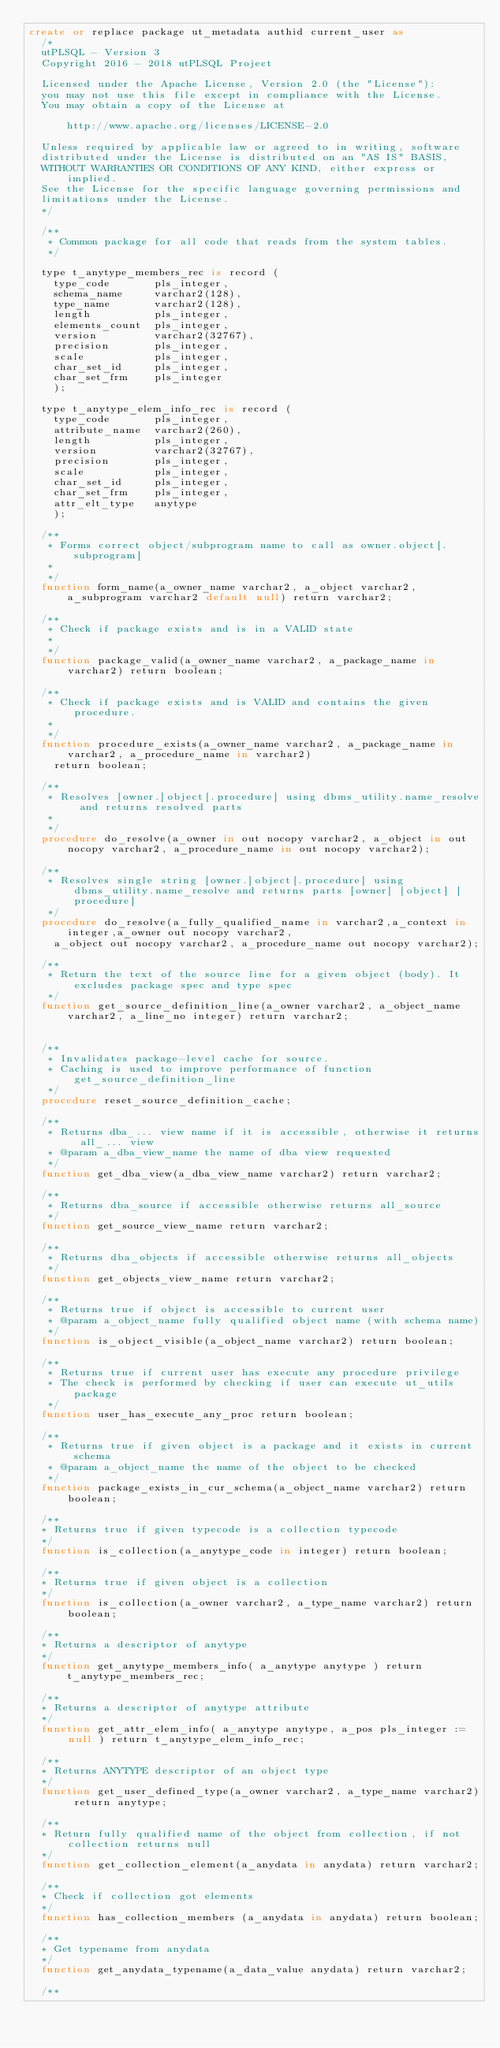Convert code to text. <code><loc_0><loc_0><loc_500><loc_500><_SQL_>create or replace package ut_metadata authid current_user as
  /*
  utPLSQL - Version 3
  Copyright 2016 - 2018 utPLSQL Project

  Licensed under the Apache License, Version 2.0 (the "License"):
  you may not use this file except in compliance with the License.
  You may obtain a copy of the License at

      http://www.apache.org/licenses/LICENSE-2.0

  Unless required by applicable law or agreed to in writing, software
  distributed under the License is distributed on an "AS IS" BASIS,
  WITHOUT WARRANTIES OR CONDITIONS OF ANY KIND, either express or implied.
  See the License for the specific language governing permissions and
  limitations under the License.
  */

  /**
   * Common package for all code that reads from the system tables.
   */

  type t_anytype_members_rec is record (
    type_code       pls_integer,
    schema_name     varchar2(128),
    type_name       varchar2(128),
    length          pls_integer,
    elements_count  pls_integer,
    version         varchar2(32767),
    precision       pls_integer,
    scale           pls_integer,
    char_set_id     pls_integer,
    char_set_frm    pls_integer
    );

  type t_anytype_elem_info_rec is record (
    type_code       pls_integer,
    attribute_name  varchar2(260),
    length          pls_integer,
    version         varchar2(32767),
    precision       pls_integer,
    scale           pls_integer,
    char_set_id     pls_integer,
    char_set_frm    pls_integer,
    attr_elt_type   anytype
    );

  /**
   * Forms correct object/subprogram name to call as owner.object[.subprogram]
   *
   */
  function form_name(a_owner_name varchar2, a_object varchar2, a_subprogram varchar2 default null) return varchar2;

  /**
   * Check if package exists and is in a VALID state
   *
   */
  function package_valid(a_owner_name varchar2, a_package_name in varchar2) return boolean;

  /**
   * Check if package exists and is VALID and contains the given procedure.
   *
   */
  function procedure_exists(a_owner_name varchar2, a_package_name in varchar2, a_procedure_name in varchar2)
    return boolean;

  /**
   * Resolves [owner.]object[.procedure] using dbms_utility.name_resolve and returns resolved parts
   *
   */
  procedure do_resolve(a_owner in out nocopy varchar2, a_object in out nocopy varchar2, a_procedure_name in out nocopy varchar2);

  /**
   * Resolves single string [owner.]object[.procedure] using dbms_utility.name_resolve and returns parts [owner] [object] [procedure]
   */
  procedure do_resolve(a_fully_qualified_name in varchar2,a_context in integer,a_owner out nocopy varchar2, 
    a_object out nocopy varchar2, a_procedure_name out nocopy varchar2);

  /**
   * Return the text of the source line for a given object (body). It excludes package spec and type spec
   */
  function get_source_definition_line(a_owner varchar2, a_object_name varchar2, a_line_no integer) return varchar2;


  /**
   * Invalidates package-level cache for source.
   * Caching is used to improve performance of function get_source_definition_line
   */
  procedure reset_source_definition_cache;

  /**
   * Returns dba_... view name if it is accessible, otherwise it returns all_... view
   * @param a_dba_view_name the name of dba view requested
   */
  function get_dba_view(a_dba_view_name varchar2) return varchar2;

  /**
   * Returns dba_source if accessible otherwise returns all_source
   */
  function get_source_view_name return varchar2;

  /**
   * Returns dba_objects if accessible otherwise returns all_objects
   */
  function get_objects_view_name return varchar2;

  /**
   * Returns true if object is accessible to current user
   * @param a_object_name fully qualified object name (with schema name)
   */
  function is_object_visible(a_object_name varchar2) return boolean;

  /**
   * Returns true if current user has execute any procedure privilege
   * The check is performed by checking if user can execute ut_utils package
   */
  function user_has_execute_any_proc return boolean;

  /**
   * Returns true if given object is a package and it exists in current schema
   * @param a_object_name the name of the object to be checked
   */
  function package_exists_in_cur_schema(a_object_name varchar2) return boolean;

  /**
  * Returns true if given typecode is a collection typecode
  */
  function is_collection(a_anytype_code in integer) return boolean;

  /**
  * Returns true if given object is a collection
  */
  function is_collection(a_owner varchar2, a_type_name varchar2) return boolean;

  /**
  * Returns a descriptor of anytype
  */
  function get_anytype_members_info( a_anytype anytype ) return t_anytype_members_rec;

  /**
  * Returns a descriptor of anytype attribute
  */
  function get_attr_elem_info( a_anytype anytype, a_pos pls_integer := null ) return t_anytype_elem_info_rec;

  /**
  * Returns ANYTYPE descriptor of an object type
  */
  function get_user_defined_type(a_owner varchar2, a_type_name varchar2) return anytype;
  
  /**
  * Return fully qualified name of the object from collection, if not collection returns null
  */
  function get_collection_element(a_anydata in anydata) return varchar2;

  /**
  * Check if collection got elements
  */  
  function has_collection_members (a_anydata in anydata) return boolean;

  /**
  * Get typename from anydata
  */   
  function get_anydata_typename(a_data_value anydata) return varchar2;

  /**</code> 